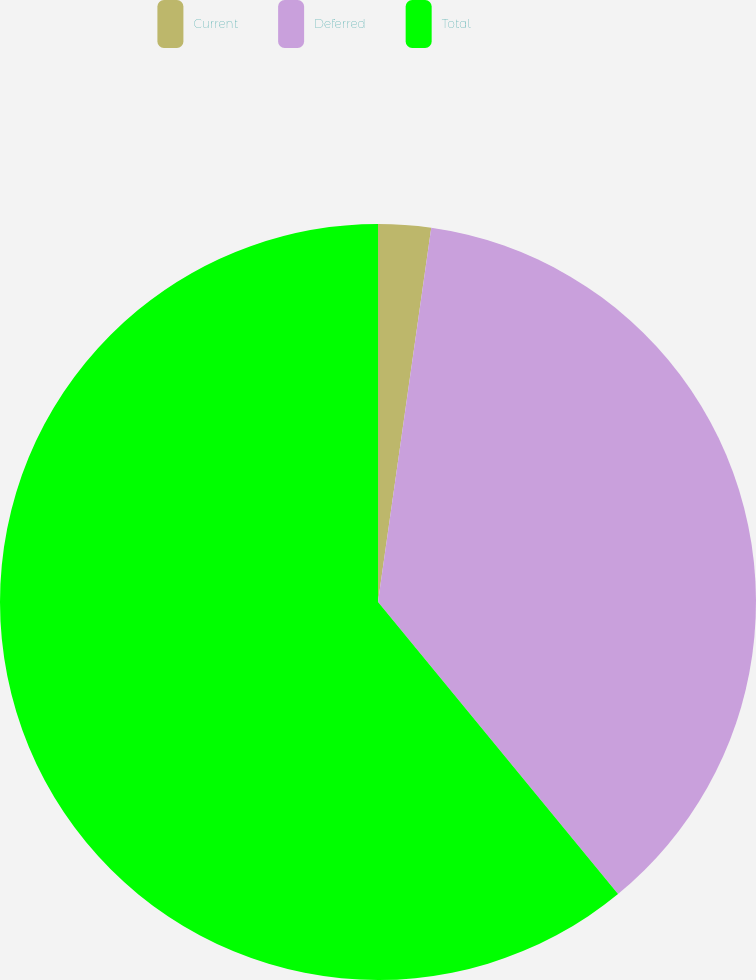Convert chart to OTSL. <chart><loc_0><loc_0><loc_500><loc_500><pie_chart><fcel>Current<fcel>Deferred<fcel>Total<nl><fcel>2.25%<fcel>36.8%<fcel>60.95%<nl></chart> 